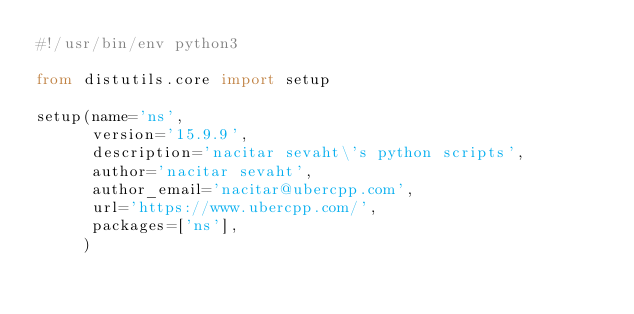<code> <loc_0><loc_0><loc_500><loc_500><_Python_>#!/usr/bin/env python3

from distutils.core import setup

setup(name='ns',
      version='15.9.9',
      description='nacitar sevaht\'s python scripts',
      author='nacitar sevaht',
      author_email='nacitar@ubercpp.com',
      url='https://www.ubercpp.com/',
      packages=['ns'],
     )
</code> 